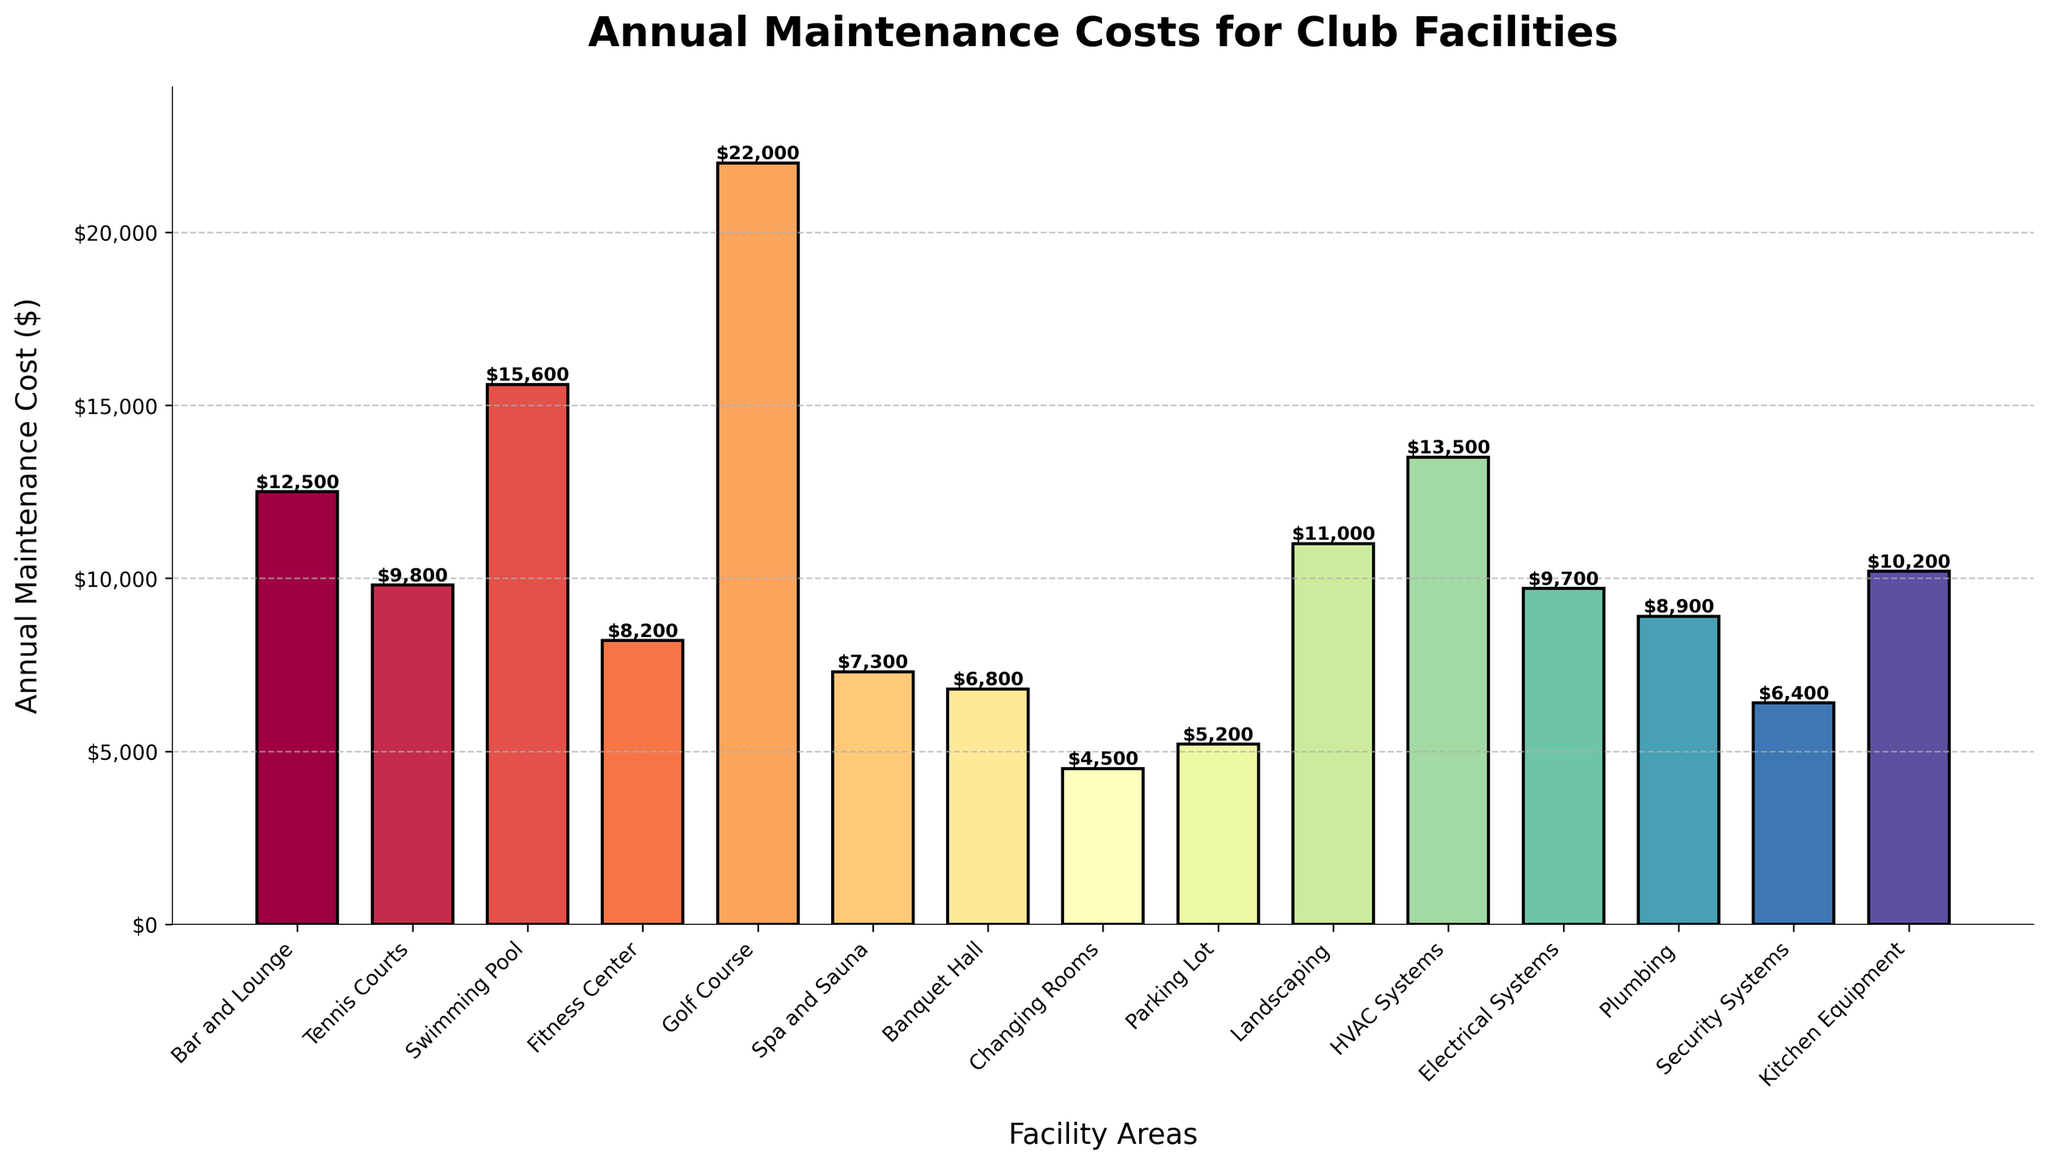Which facility area has the highest annual maintenance cost? The bar chart shows each area with its corresponding maintenance cost. The bar representing the Golf Course is the tallest, indicating the highest annual maintenance cost.
Answer: Golf Course Which facility areas have maintenance costs greater than $10,000 annually? By examining the height of the bars and the labels, the areas with annual maintenance costs exceeding $10,000 are identified as Bar and Lounge, Swimming Pool, Golf Course, HVAC Systems, Landscaping, and Kitchen Equipment.
Answer: Bar and Lounge, Swimming Pool, Golf Course, HVAC Systems, Landscaping, Kitchen Equipment How much more does it cost annually to maintain the Swimming Pool compared to the Tennis Courts? The annual maintenance cost for the Swimming Pool is $15,600, and for the Tennis Courts, it is $9,800. The difference is calculated as $15,600 - $9,800.
Answer: $5,800 What is the total annual maintenance cost for the Bar and Lounge, Tennis Courts, and Fitness Center? Adding the annual maintenance costs for these areas: Bar and Lounge ($12,500) + Tennis Courts ($9,800) + Fitness Center ($8,200).
Answer: $30,500 What is the approximate total annual maintenance cost for all facility areas combined? Summing up the maintenance costs for each area: $12,500 + $9,800 + $15,600 + $8,200 + $22,000 + $7,300 + $6,800 + $4,500 + $5,200 + $11,000 + $13,500 + $9,700 + $8,900 + $6,400 + $10,200. The precise calculation results in a total around $151,600.
Answer: $151,600 Which area incurs a lower annual maintenance cost: Electrical Systems or Plumbing? By comparing the bars representing Electrical Systems and Plumbing, Electrical Systems has a cost of $9,700, while Plumbing stands at $8,900.
Answer: Plumbing Rank the top three facility areas with the lowest maintenance costs. Identifying the smallest bars visually and verifying their labels: Changing Rooms ($4,500), Banquet Hall ($6,800), and Parking Lot ($5,200).
Answer: Changing Rooms, Banquet Hall, Parking Lot Is the maintenance cost of the Golf Course more than twice that of the Fitness Center? The annual maintenance cost for the Golf Course is $22,000, and for the Fitness Center, it is $8,200. Doubling the Fitness Center's cost gives $8,200 * 2 = $16,400. Checking if $22,000 > $16,400 confirms the condition.
Answer: Yes What is the combined annual maintenance cost for Spa and Sauna and Security Systems? Adding together the costs for Spa and Sauna ($7,300) and Security Systems ($6,400).
Answer: $13,700 Which facility area has an annual maintenance cost closest to $10,000? By looking at the bars and their heights relative to $10,000, Kitchen Equipment has a cost of $10,200, which is closest to $10,000.
Answer: Kitchen Equipment 